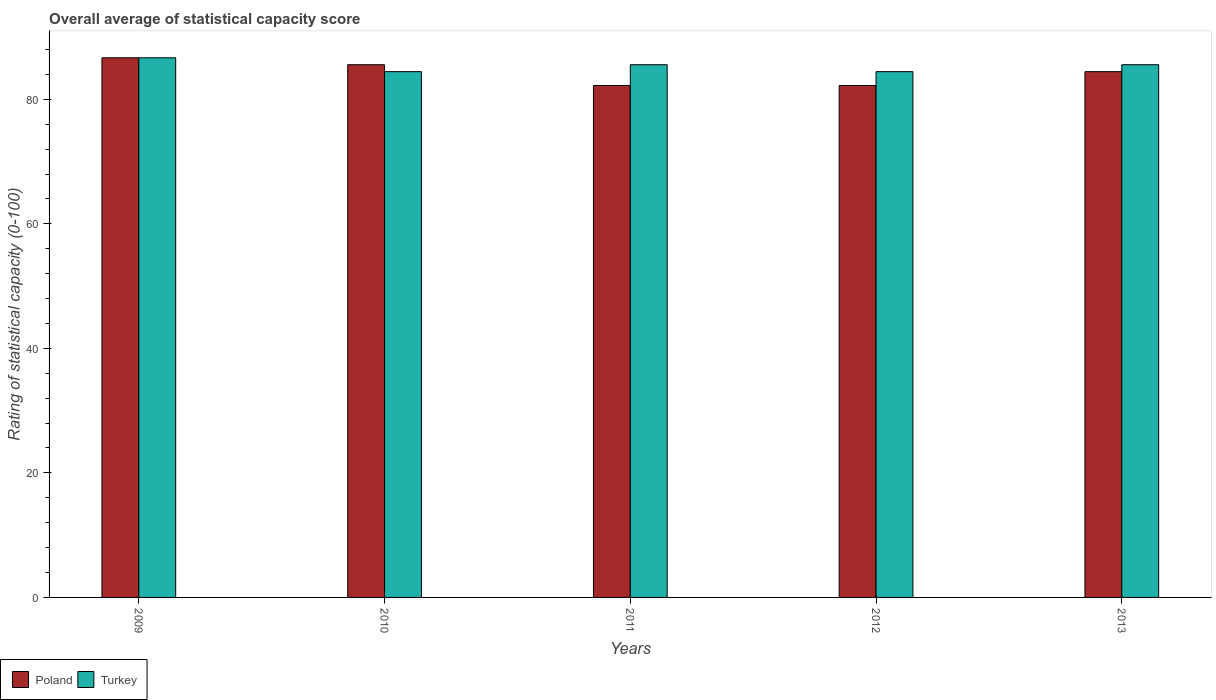How many bars are there on the 3rd tick from the left?
Provide a succinct answer. 2. What is the label of the 1st group of bars from the left?
Keep it short and to the point. 2009. In how many cases, is the number of bars for a given year not equal to the number of legend labels?
Keep it short and to the point. 0. What is the rating of statistical capacity in Turkey in 2013?
Your answer should be very brief. 85.56. Across all years, what is the maximum rating of statistical capacity in Turkey?
Provide a short and direct response. 86.67. Across all years, what is the minimum rating of statistical capacity in Poland?
Ensure brevity in your answer.  82.22. In which year was the rating of statistical capacity in Turkey maximum?
Your answer should be compact. 2009. In which year was the rating of statistical capacity in Poland minimum?
Provide a short and direct response. 2011. What is the total rating of statistical capacity in Poland in the graph?
Make the answer very short. 421.11. What is the difference between the rating of statistical capacity in Turkey in 2012 and that in 2013?
Your answer should be compact. -1.11. What is the difference between the rating of statistical capacity in Poland in 2010 and the rating of statistical capacity in Turkey in 2012?
Provide a short and direct response. 1.11. What is the average rating of statistical capacity in Poland per year?
Give a very brief answer. 84.22. In the year 2009, what is the difference between the rating of statistical capacity in Turkey and rating of statistical capacity in Poland?
Offer a terse response. 0. In how many years, is the rating of statistical capacity in Turkey greater than 76?
Ensure brevity in your answer.  5. What is the ratio of the rating of statistical capacity in Poland in 2009 to that in 2013?
Your response must be concise. 1.03. What is the difference between the highest and the second highest rating of statistical capacity in Turkey?
Give a very brief answer. 1.11. What is the difference between the highest and the lowest rating of statistical capacity in Poland?
Make the answer very short. 4.44. Is the sum of the rating of statistical capacity in Turkey in 2009 and 2013 greater than the maximum rating of statistical capacity in Poland across all years?
Your response must be concise. Yes. What does the 2nd bar from the right in 2011 represents?
Your answer should be compact. Poland. How many bars are there?
Give a very brief answer. 10. How many years are there in the graph?
Your answer should be very brief. 5. What is the difference between two consecutive major ticks on the Y-axis?
Offer a very short reply. 20. Are the values on the major ticks of Y-axis written in scientific E-notation?
Provide a succinct answer. No. How many legend labels are there?
Your response must be concise. 2. How are the legend labels stacked?
Provide a succinct answer. Horizontal. What is the title of the graph?
Offer a very short reply. Overall average of statistical capacity score. What is the label or title of the X-axis?
Your response must be concise. Years. What is the label or title of the Y-axis?
Your answer should be very brief. Rating of statistical capacity (0-100). What is the Rating of statistical capacity (0-100) in Poland in 2009?
Your response must be concise. 86.67. What is the Rating of statistical capacity (0-100) in Turkey in 2009?
Offer a terse response. 86.67. What is the Rating of statistical capacity (0-100) in Poland in 2010?
Make the answer very short. 85.56. What is the Rating of statistical capacity (0-100) of Turkey in 2010?
Your response must be concise. 84.44. What is the Rating of statistical capacity (0-100) of Poland in 2011?
Keep it short and to the point. 82.22. What is the Rating of statistical capacity (0-100) in Turkey in 2011?
Give a very brief answer. 85.56. What is the Rating of statistical capacity (0-100) of Poland in 2012?
Provide a short and direct response. 82.22. What is the Rating of statistical capacity (0-100) of Turkey in 2012?
Provide a short and direct response. 84.44. What is the Rating of statistical capacity (0-100) in Poland in 2013?
Offer a terse response. 84.44. What is the Rating of statistical capacity (0-100) of Turkey in 2013?
Provide a short and direct response. 85.56. Across all years, what is the maximum Rating of statistical capacity (0-100) in Poland?
Your response must be concise. 86.67. Across all years, what is the maximum Rating of statistical capacity (0-100) in Turkey?
Your answer should be very brief. 86.67. Across all years, what is the minimum Rating of statistical capacity (0-100) in Poland?
Your response must be concise. 82.22. Across all years, what is the minimum Rating of statistical capacity (0-100) in Turkey?
Make the answer very short. 84.44. What is the total Rating of statistical capacity (0-100) of Poland in the graph?
Your answer should be compact. 421.11. What is the total Rating of statistical capacity (0-100) of Turkey in the graph?
Your answer should be compact. 426.67. What is the difference between the Rating of statistical capacity (0-100) in Poland in 2009 and that in 2010?
Keep it short and to the point. 1.11. What is the difference between the Rating of statistical capacity (0-100) in Turkey in 2009 and that in 2010?
Your answer should be compact. 2.22. What is the difference between the Rating of statistical capacity (0-100) in Poland in 2009 and that in 2011?
Your response must be concise. 4.44. What is the difference between the Rating of statistical capacity (0-100) in Turkey in 2009 and that in 2011?
Keep it short and to the point. 1.11. What is the difference between the Rating of statistical capacity (0-100) in Poland in 2009 and that in 2012?
Your response must be concise. 4.44. What is the difference between the Rating of statistical capacity (0-100) in Turkey in 2009 and that in 2012?
Keep it short and to the point. 2.22. What is the difference between the Rating of statistical capacity (0-100) of Poland in 2009 and that in 2013?
Keep it short and to the point. 2.22. What is the difference between the Rating of statistical capacity (0-100) of Poland in 2010 and that in 2011?
Offer a terse response. 3.33. What is the difference between the Rating of statistical capacity (0-100) of Turkey in 2010 and that in 2011?
Give a very brief answer. -1.11. What is the difference between the Rating of statistical capacity (0-100) of Poland in 2010 and that in 2012?
Ensure brevity in your answer.  3.33. What is the difference between the Rating of statistical capacity (0-100) of Turkey in 2010 and that in 2012?
Offer a very short reply. 0. What is the difference between the Rating of statistical capacity (0-100) in Poland in 2010 and that in 2013?
Give a very brief answer. 1.11. What is the difference between the Rating of statistical capacity (0-100) of Turkey in 2010 and that in 2013?
Your response must be concise. -1.11. What is the difference between the Rating of statistical capacity (0-100) of Turkey in 2011 and that in 2012?
Your answer should be compact. 1.11. What is the difference between the Rating of statistical capacity (0-100) in Poland in 2011 and that in 2013?
Offer a terse response. -2.22. What is the difference between the Rating of statistical capacity (0-100) in Turkey in 2011 and that in 2013?
Your answer should be compact. -0. What is the difference between the Rating of statistical capacity (0-100) of Poland in 2012 and that in 2013?
Make the answer very short. -2.22. What is the difference between the Rating of statistical capacity (0-100) of Turkey in 2012 and that in 2013?
Ensure brevity in your answer.  -1.11. What is the difference between the Rating of statistical capacity (0-100) in Poland in 2009 and the Rating of statistical capacity (0-100) in Turkey in 2010?
Provide a succinct answer. 2.22. What is the difference between the Rating of statistical capacity (0-100) of Poland in 2009 and the Rating of statistical capacity (0-100) of Turkey in 2011?
Keep it short and to the point. 1.11. What is the difference between the Rating of statistical capacity (0-100) in Poland in 2009 and the Rating of statistical capacity (0-100) in Turkey in 2012?
Provide a succinct answer. 2.22. What is the difference between the Rating of statistical capacity (0-100) of Poland in 2009 and the Rating of statistical capacity (0-100) of Turkey in 2013?
Your answer should be very brief. 1.11. What is the difference between the Rating of statistical capacity (0-100) in Poland in 2010 and the Rating of statistical capacity (0-100) in Turkey in 2011?
Offer a very short reply. 0. What is the difference between the Rating of statistical capacity (0-100) in Poland in 2010 and the Rating of statistical capacity (0-100) in Turkey in 2012?
Offer a terse response. 1.11. What is the difference between the Rating of statistical capacity (0-100) in Poland in 2010 and the Rating of statistical capacity (0-100) in Turkey in 2013?
Give a very brief answer. 0. What is the difference between the Rating of statistical capacity (0-100) in Poland in 2011 and the Rating of statistical capacity (0-100) in Turkey in 2012?
Provide a short and direct response. -2.22. What is the difference between the Rating of statistical capacity (0-100) of Poland in 2011 and the Rating of statistical capacity (0-100) of Turkey in 2013?
Provide a short and direct response. -3.33. What is the difference between the Rating of statistical capacity (0-100) in Poland in 2012 and the Rating of statistical capacity (0-100) in Turkey in 2013?
Your answer should be compact. -3.33. What is the average Rating of statistical capacity (0-100) in Poland per year?
Your answer should be very brief. 84.22. What is the average Rating of statistical capacity (0-100) in Turkey per year?
Provide a succinct answer. 85.33. In the year 2009, what is the difference between the Rating of statistical capacity (0-100) in Poland and Rating of statistical capacity (0-100) in Turkey?
Ensure brevity in your answer.  0. In the year 2010, what is the difference between the Rating of statistical capacity (0-100) in Poland and Rating of statistical capacity (0-100) in Turkey?
Provide a short and direct response. 1.11. In the year 2011, what is the difference between the Rating of statistical capacity (0-100) of Poland and Rating of statistical capacity (0-100) of Turkey?
Your response must be concise. -3.33. In the year 2012, what is the difference between the Rating of statistical capacity (0-100) in Poland and Rating of statistical capacity (0-100) in Turkey?
Your answer should be compact. -2.22. In the year 2013, what is the difference between the Rating of statistical capacity (0-100) of Poland and Rating of statistical capacity (0-100) of Turkey?
Ensure brevity in your answer.  -1.11. What is the ratio of the Rating of statistical capacity (0-100) of Turkey in 2009 to that in 2010?
Keep it short and to the point. 1.03. What is the ratio of the Rating of statistical capacity (0-100) of Poland in 2009 to that in 2011?
Offer a very short reply. 1.05. What is the ratio of the Rating of statistical capacity (0-100) of Turkey in 2009 to that in 2011?
Make the answer very short. 1.01. What is the ratio of the Rating of statistical capacity (0-100) of Poland in 2009 to that in 2012?
Provide a short and direct response. 1.05. What is the ratio of the Rating of statistical capacity (0-100) of Turkey in 2009 to that in 2012?
Your response must be concise. 1.03. What is the ratio of the Rating of statistical capacity (0-100) in Poland in 2009 to that in 2013?
Your answer should be compact. 1.03. What is the ratio of the Rating of statistical capacity (0-100) of Turkey in 2009 to that in 2013?
Your response must be concise. 1.01. What is the ratio of the Rating of statistical capacity (0-100) in Poland in 2010 to that in 2011?
Your response must be concise. 1.04. What is the ratio of the Rating of statistical capacity (0-100) in Turkey in 2010 to that in 2011?
Make the answer very short. 0.99. What is the ratio of the Rating of statistical capacity (0-100) of Poland in 2010 to that in 2012?
Ensure brevity in your answer.  1.04. What is the ratio of the Rating of statistical capacity (0-100) in Poland in 2010 to that in 2013?
Offer a very short reply. 1.01. What is the ratio of the Rating of statistical capacity (0-100) of Turkey in 2010 to that in 2013?
Give a very brief answer. 0.99. What is the ratio of the Rating of statistical capacity (0-100) of Turkey in 2011 to that in 2012?
Give a very brief answer. 1.01. What is the ratio of the Rating of statistical capacity (0-100) in Poland in 2011 to that in 2013?
Your answer should be very brief. 0.97. What is the ratio of the Rating of statistical capacity (0-100) of Turkey in 2011 to that in 2013?
Your response must be concise. 1. What is the ratio of the Rating of statistical capacity (0-100) of Poland in 2012 to that in 2013?
Provide a succinct answer. 0.97. What is the difference between the highest and the second highest Rating of statistical capacity (0-100) in Poland?
Provide a succinct answer. 1.11. What is the difference between the highest and the lowest Rating of statistical capacity (0-100) in Poland?
Offer a very short reply. 4.44. What is the difference between the highest and the lowest Rating of statistical capacity (0-100) of Turkey?
Provide a short and direct response. 2.22. 